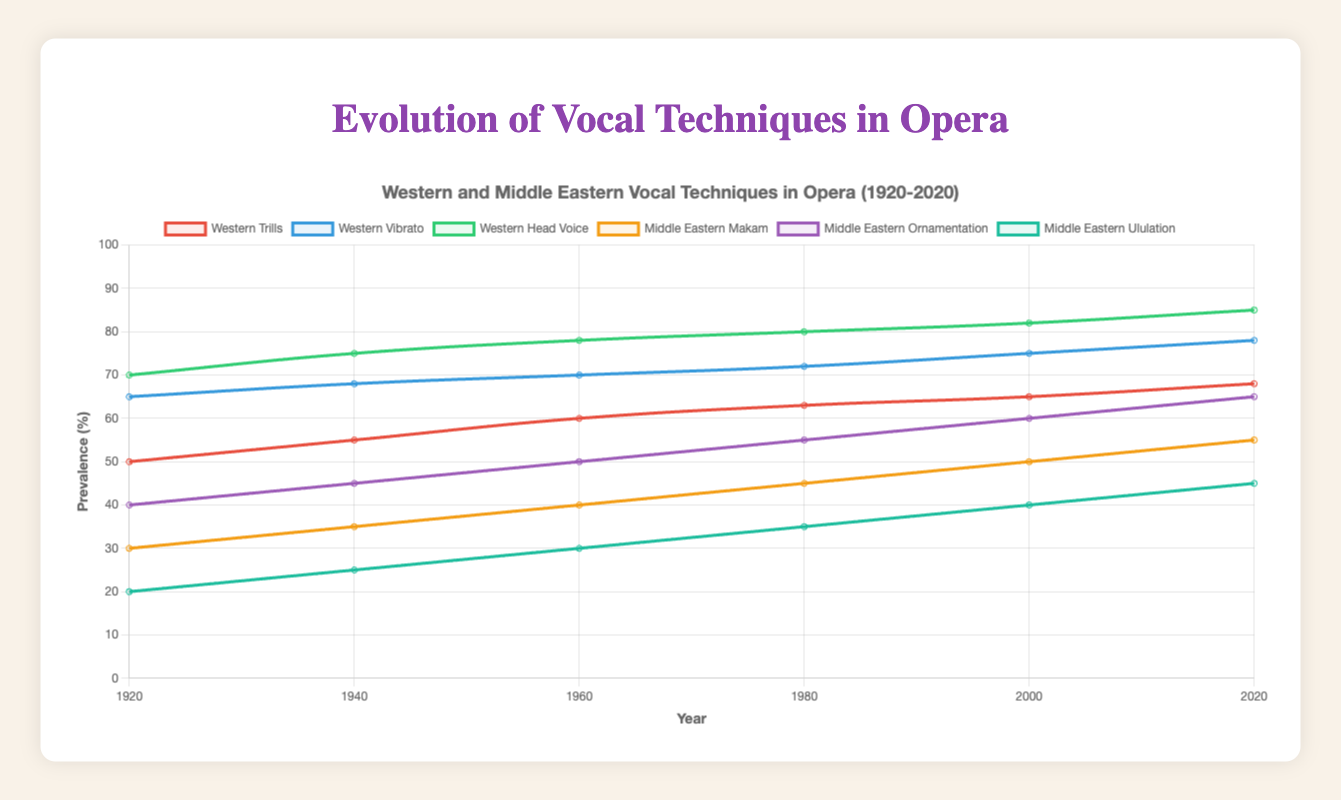How have Western Trills evolved from 1920 to 2020? Western Trills have increased from 50 in 1920 to 68 in 2020. Add 5 increments per each 20-year period: 50 (1920), 55 (1940), 60 (1960), 63 (1980), 65 (2000), 68 (2020).
Answer: They have increased Which vocal technique shows the highest percentage increase from 1920 to 2020? Comparing initial and final values for each technique, Western Head Voice increases from 70 to 85 (15), Middle Eastern Makam from 30 to 55 (25), Middle Eastern Ornamentation from 40 to 65 (25). Makam and Ornamentation increased by 25 each, making them the highest.
Answer: Middle Eastern Makam and Middle Eastern Ornamentation What is the average prevalence of Middle Eastern Ornamentation in 1980 and in 2000? Average is calculated by summing values and dividing by the number of values. Middle Eastern Ornamentation in 1980 is 55 and in 2000 is 60, so the average is (55+60)/2 = 57.5.
Answer: 57.5 Which vocal technique was the least prevalent in 1960? By comparing the figures in the year 1960, Middle Eastern Ululation has the lowest value of 30.
Answer: Middle Eastern Ululation In what year did Western Vibrato surpass 70 in prevalence? The graph shows Western Vibrato reached 70 in the year 1960.
Answer: 1960 How does the trend of Middle Eastern Ululation compare to that of Western Trills from 1920 to 2020? Middle Eastern Ululation starts at 20 and increases to 45. Western Trills start at 50 and increases to 68. Both show an increasing trend, but Western Trills started higher and grew steadily, while Middle Eastern Ululation had a more gradual increase.
Answer: Both are increasing; Western Trills have a higher initial value and steady increase What is the combined prevalence of Middle Eastern Makam and Middle Eastern Ululation in 2020? Sum the prevalence values of the two techniques in 2020. Middle Eastern Makam is 55 and Middle Eastern Ululation is 45, so combined is 55 + 45 = 100.
Answer: 100 Compare the prevalence of Western Head Voice and Middle Eastern Ornamentation in the year 2000. In 2000, Western Head Voice is 82 and Middle Eastern Ornamentation is 60. Western Head Voice is higher by comparing the two values directly.
Answer: Western Head Voice is higher What is the trend in prevalence for all vocal techniques represented in the graph? All vocal techniques show an increasing trend. Western techniques (Trills, Vibrato, Head Voice) and Middle Eastern techniques (Makam, Ornamentation, Ululation) have all increased steadily over the century.
Answer: Increasing for all techniques Between 1940 and 1960, which vocal technique shows the highest rate of increase? Calculate the difference for each technique between 1940 and 1960: Western Trills (60-55=5), Western Vibrato (70-68=2), Western Head Voice (78-75=3), Middle Eastern Makam (40-35=5), Middle Eastern Ornamentation (50-45=5), Middle Eastern Ululation (30-25=5). All show an increase of 5 except for Western Vibrato, which only increased by 2.
Answer: Western Trills, Middle Eastern Makam, Ornamentation, and Ululation are tied 